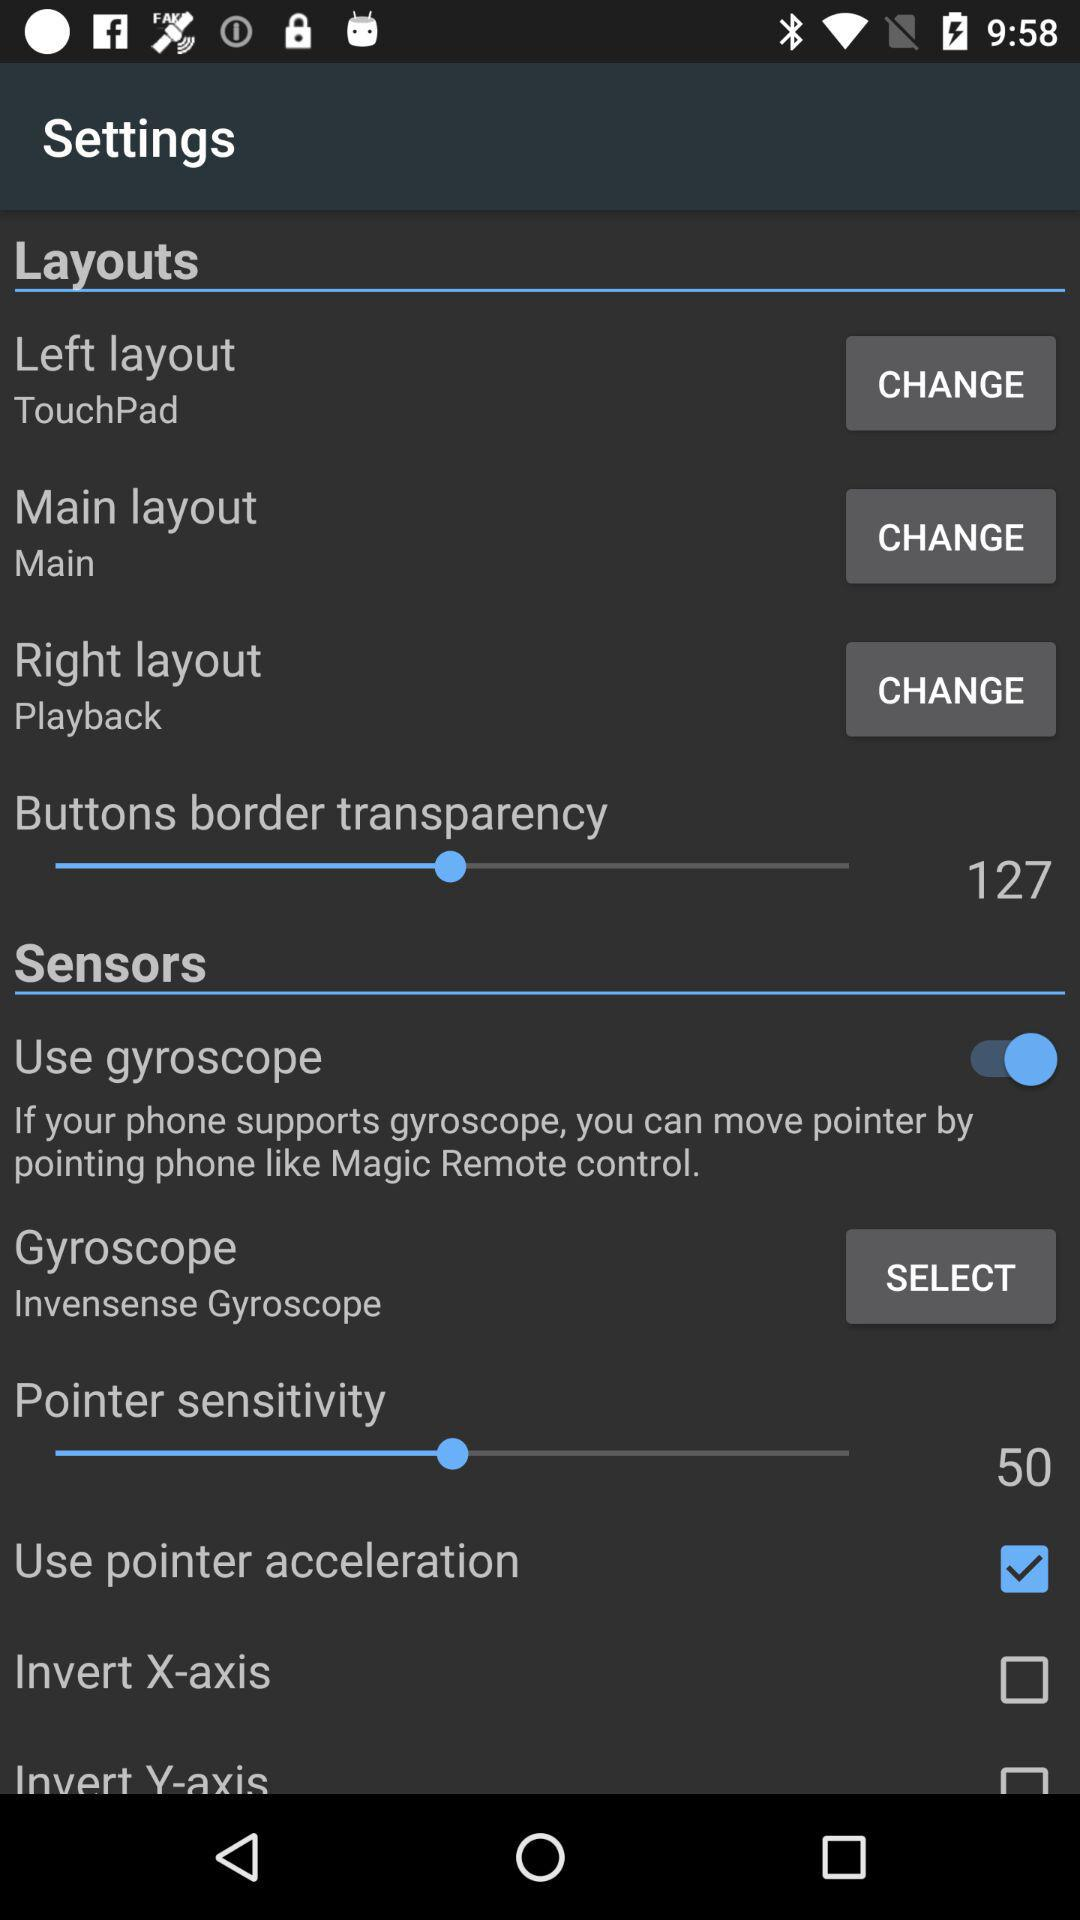What is the selected pointer sensitivity? The selected pointer sensitivity is 50. 